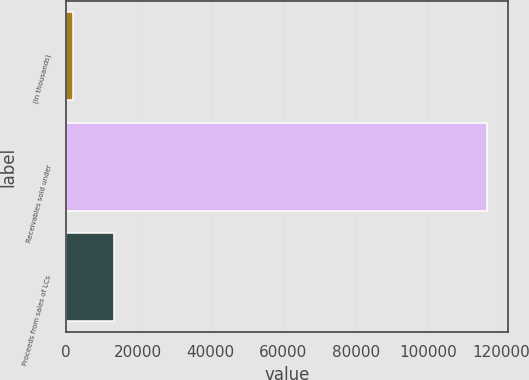Convert chart to OTSL. <chart><loc_0><loc_0><loc_500><loc_500><bar_chart><fcel>(In thousands)<fcel>Receivables sold under<fcel>Proceeds from sales of LCs<nl><fcel>2014<fcel>116292<fcel>13441.8<nl></chart> 